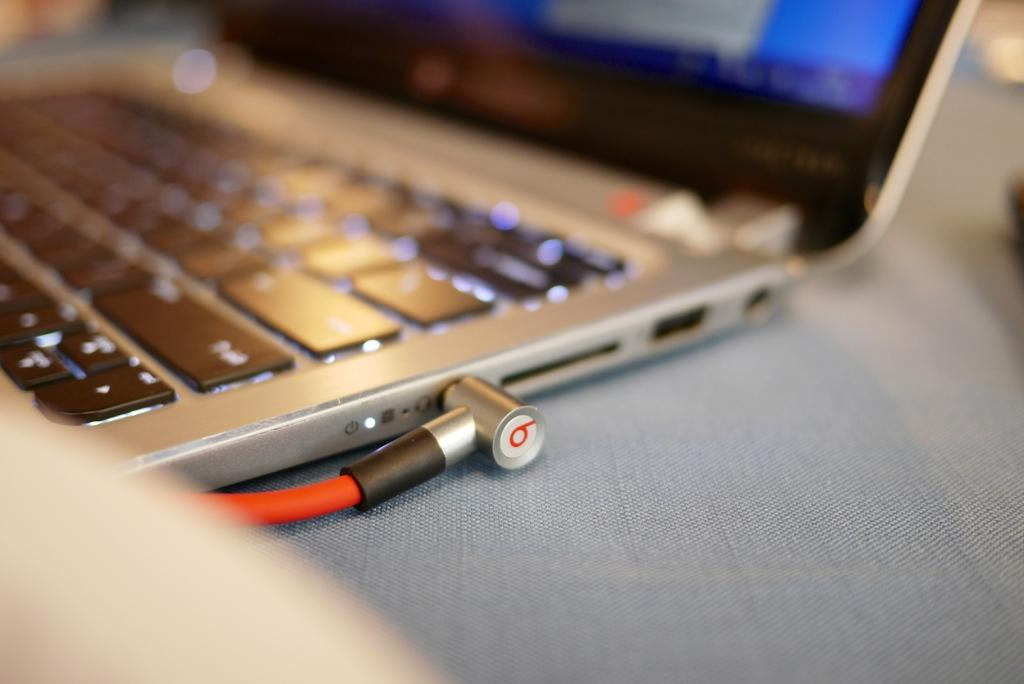What electronic device is visible in the image? There is a laptop in the image. What is connected to the laptop? The laptop has a cable. Where is the laptop and cable located? The laptop and cable are placed on a surface. What type of butter is being used to grease the hydrant in the image? There is no butter or hydrant present in the image; it features a laptop and a cable on a surface. 